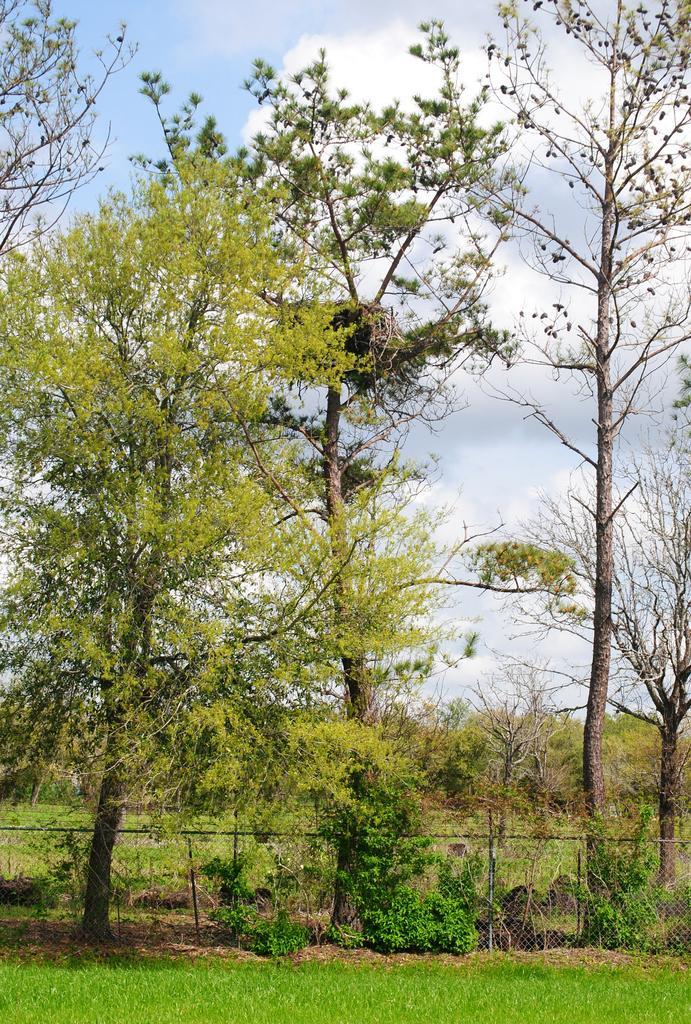How would you summarize this image in a sentence or two? In this image, we can see trees, plants, mesh and grass. In the background, we can see the trees and cloudy sky. 